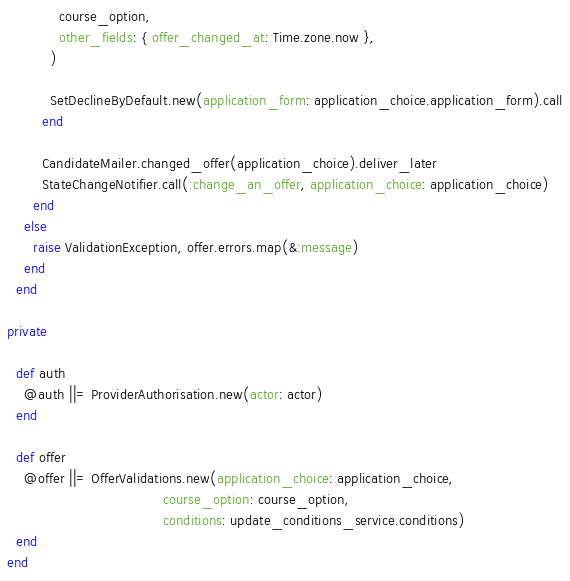Convert code to text. <code><loc_0><loc_0><loc_500><loc_500><_Ruby_>            course_option,
            other_fields: { offer_changed_at: Time.zone.now },
          )

          SetDeclineByDefault.new(application_form: application_choice.application_form).call
        end

        CandidateMailer.changed_offer(application_choice).deliver_later
        StateChangeNotifier.call(:change_an_offer, application_choice: application_choice)
      end
    else
      raise ValidationException, offer.errors.map(&:message)
    end
  end

private

  def auth
    @auth ||= ProviderAuthorisation.new(actor: actor)
  end

  def offer
    @offer ||= OfferValidations.new(application_choice: application_choice,
                                    course_option: course_option,
                                    conditions: update_conditions_service.conditions)
  end
end
</code> 